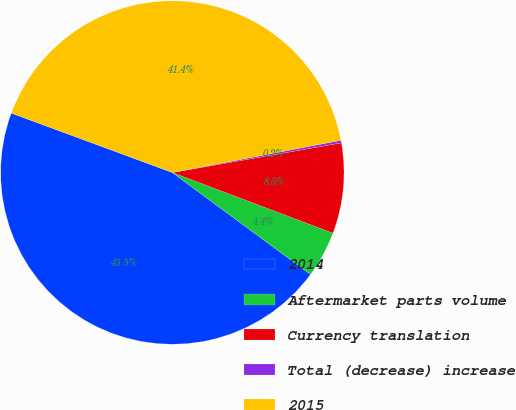Convert chart. <chart><loc_0><loc_0><loc_500><loc_500><pie_chart><fcel>2014<fcel>Aftermarket parts volume<fcel>Currency translation<fcel>Total (decrease) increase<fcel>2015<nl><fcel>45.51%<fcel>4.37%<fcel>8.51%<fcel>0.24%<fcel>41.37%<nl></chart> 